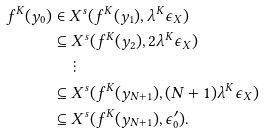<formula> <loc_0><loc_0><loc_500><loc_500>f ^ { K } ( y _ { 0 } ) & \in X ^ { s } ( f ^ { K } ( y _ { 1 } ) , \lambda ^ { K } \epsilon _ { X } ) \\ & \subseteq X ^ { s } ( f ^ { K } ( y _ { 2 } ) , 2 \lambda ^ { K } \epsilon _ { X } ) \\ & \quad \vdots \\ & \subseteq X ^ { s } ( f ^ { K } ( y _ { N + 1 } ) , ( N + 1 ) \lambda ^ { K } \epsilon _ { X } ) \\ & \subseteq X ^ { s } ( f ^ { K } ( y _ { N + 1 } ) , \epsilon _ { 0 } ^ { \prime } ) .</formula> 